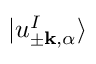Convert formula to latex. <formula><loc_0><loc_0><loc_500><loc_500>| u _ { \pm k , \alpha } ^ { I } \rangle</formula> 